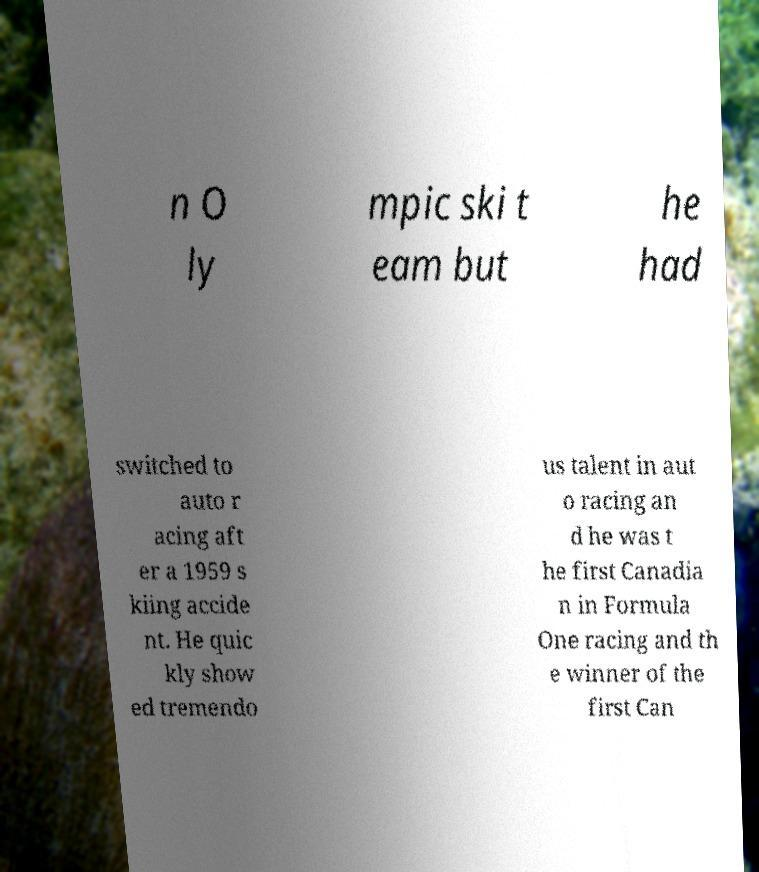Could you extract and type out the text from this image? n O ly mpic ski t eam but he had switched to auto r acing aft er a 1959 s kiing accide nt. He quic kly show ed tremendo us talent in aut o racing an d he was t he first Canadia n in Formula One racing and th e winner of the first Can 